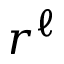Convert formula to latex. <formula><loc_0><loc_0><loc_500><loc_500>r ^ { \ell }</formula> 